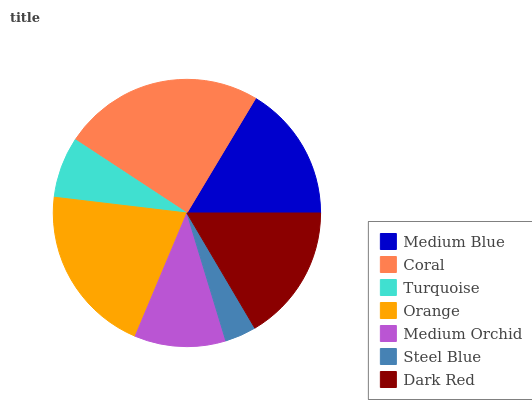Is Steel Blue the minimum?
Answer yes or no. Yes. Is Coral the maximum?
Answer yes or no. Yes. Is Turquoise the minimum?
Answer yes or no. No. Is Turquoise the maximum?
Answer yes or no. No. Is Coral greater than Turquoise?
Answer yes or no. Yes. Is Turquoise less than Coral?
Answer yes or no. Yes. Is Turquoise greater than Coral?
Answer yes or no. No. Is Coral less than Turquoise?
Answer yes or no. No. Is Medium Blue the high median?
Answer yes or no. Yes. Is Medium Blue the low median?
Answer yes or no. Yes. Is Turquoise the high median?
Answer yes or no. No. Is Orange the low median?
Answer yes or no. No. 